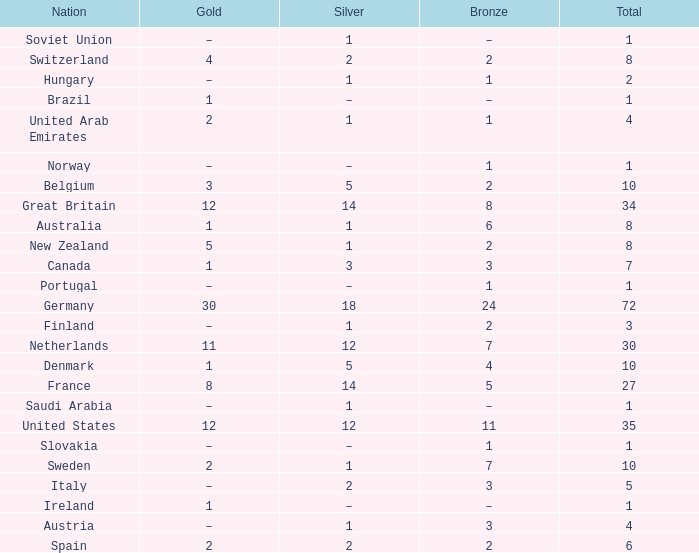What is Gold, when Silver is 5, and when Nation is Belgium? 3.0. 